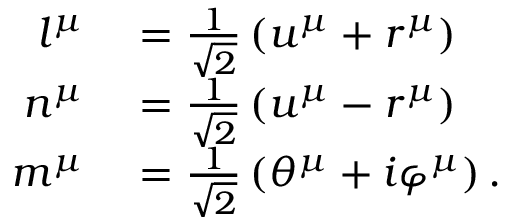<formula> <loc_0><loc_0><loc_500><loc_500>\begin{array} { r l } { l ^ { \mu } } & = \frac { 1 } { \sqrt { 2 } } \left ( u ^ { \mu } + r ^ { \mu } \right ) } \\ { n ^ { \mu } } & = \frac { 1 } { \sqrt { 2 } } \left ( u ^ { \mu } - r ^ { \mu } \right ) } \\ { m ^ { \mu } } & = \frac { 1 } { \sqrt { 2 } } \left ( \theta ^ { \mu } + i \varphi ^ { \mu } \right ) . } \end{array}</formula> 